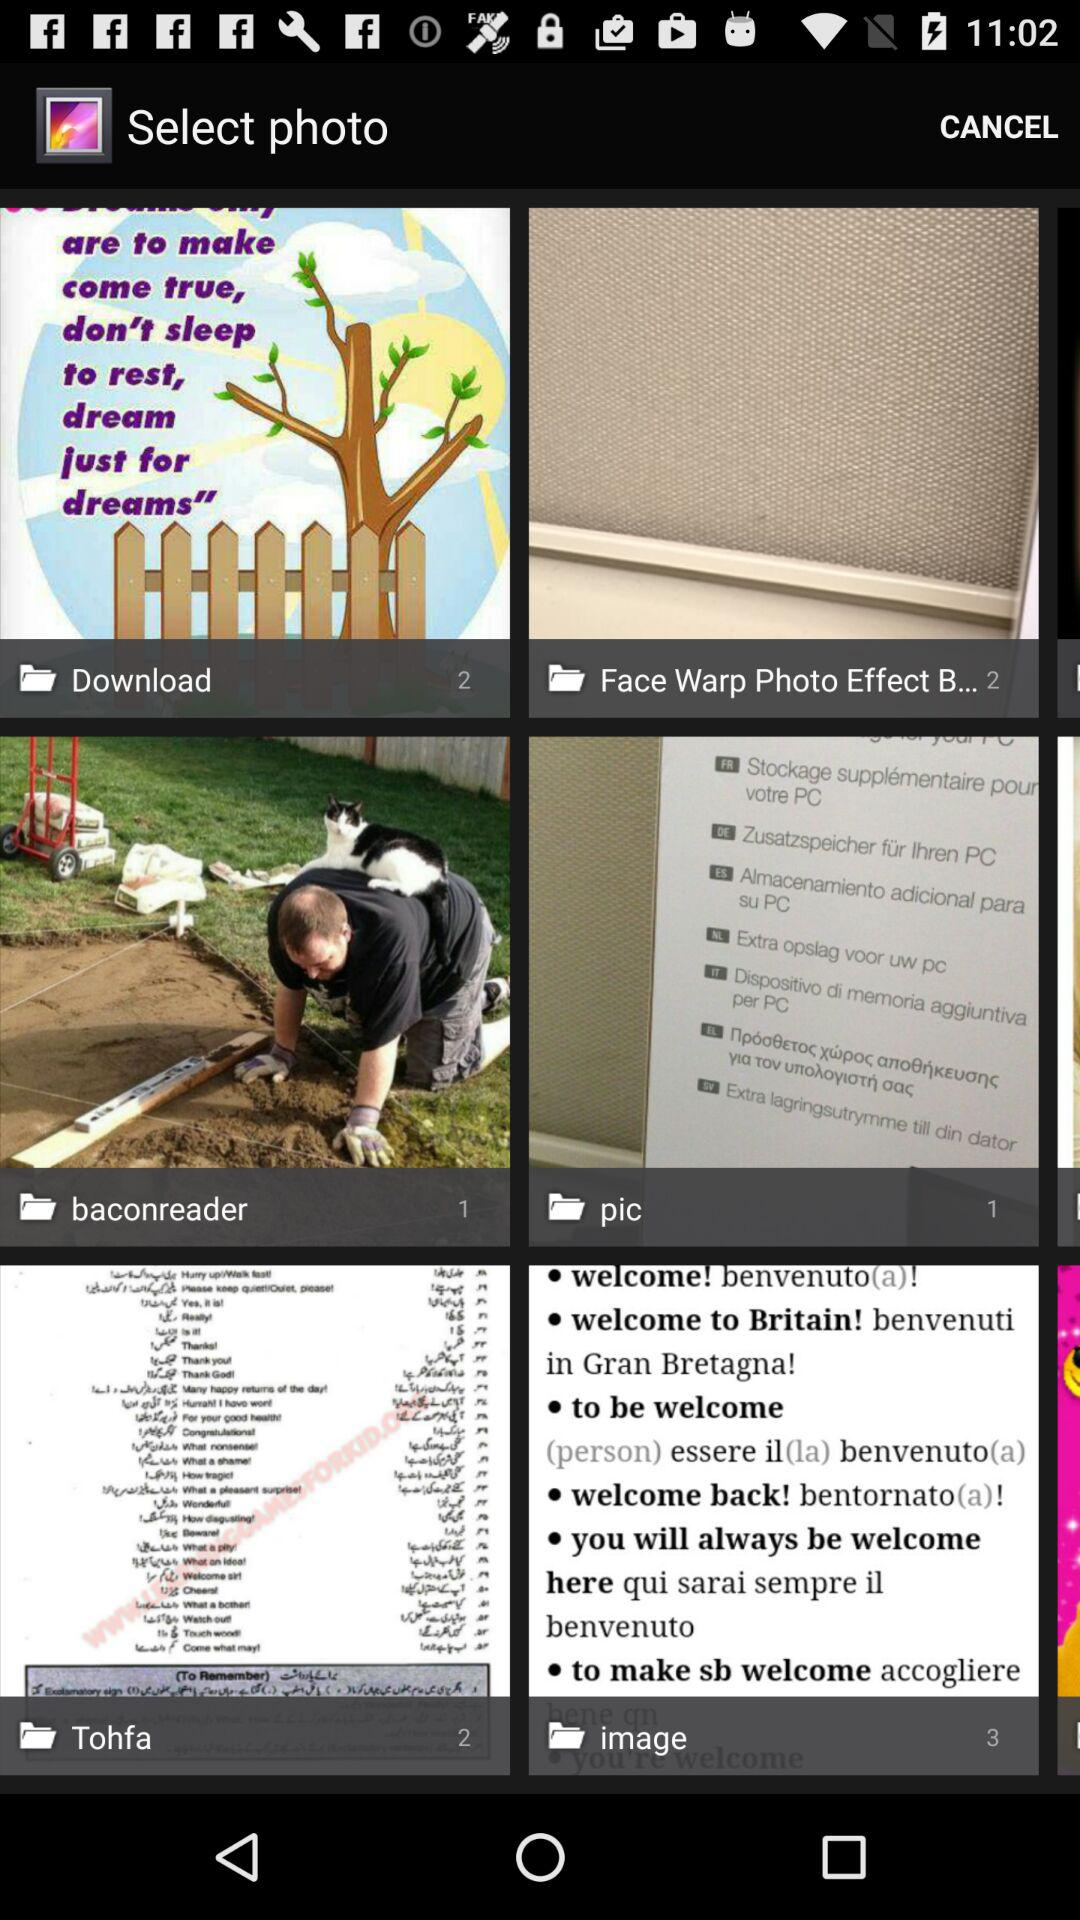How many photos are in the pic folder? There is 1 photo. 